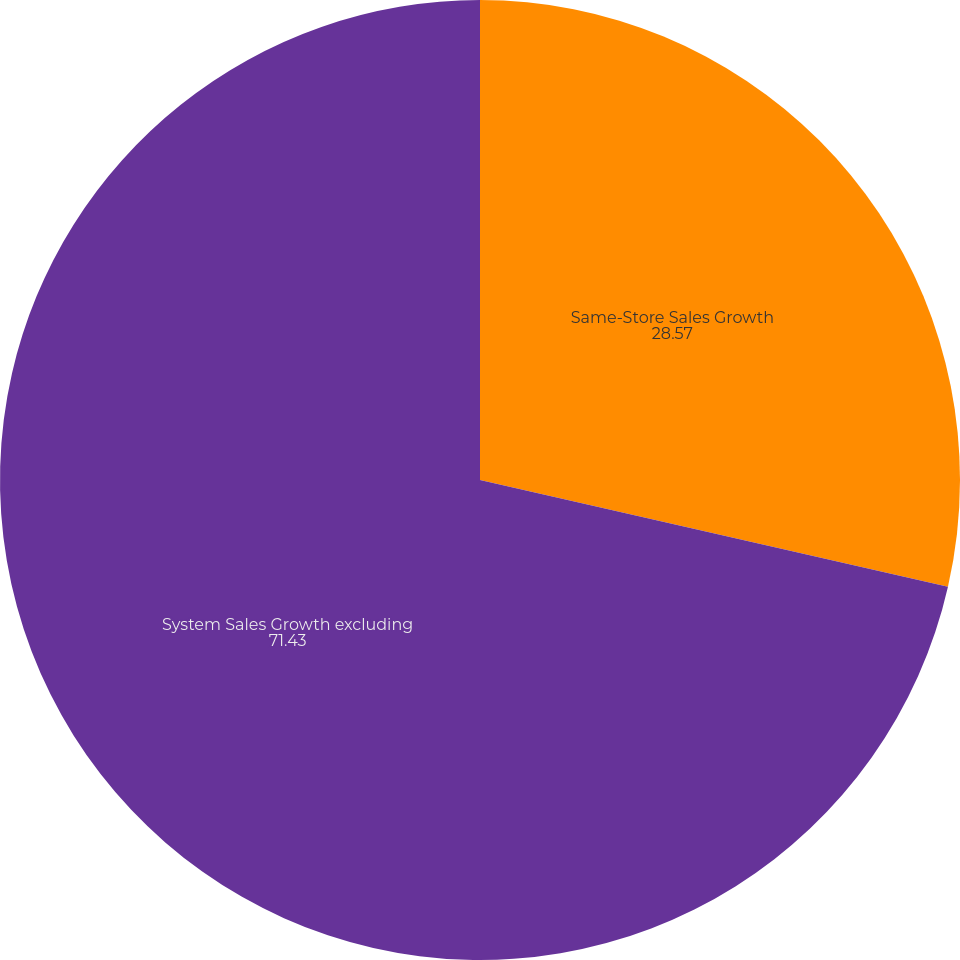Convert chart to OTSL. <chart><loc_0><loc_0><loc_500><loc_500><pie_chart><fcel>Same-Store Sales Growth<fcel>System Sales Growth excluding<nl><fcel>28.57%<fcel>71.43%<nl></chart> 